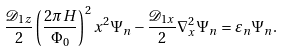<formula> <loc_0><loc_0><loc_500><loc_500>\frac { \mathcal { D } _ { 1 z } } { 2 } \left ( \frac { 2 \pi H } { \Phi _ { 0 } } \right ) ^ { 2 } x ^ { 2 } \Psi _ { n } - \frac { \mathcal { D } _ { 1 x } } { 2 } \nabla _ { x } ^ { 2 } \Psi _ { n } = \varepsilon _ { n } \Psi _ { n } .</formula> 